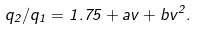<formula> <loc_0><loc_0><loc_500><loc_500>q _ { 2 } / q _ { 1 } = 1 . 7 5 + a v + b v ^ { 2 } .</formula> 